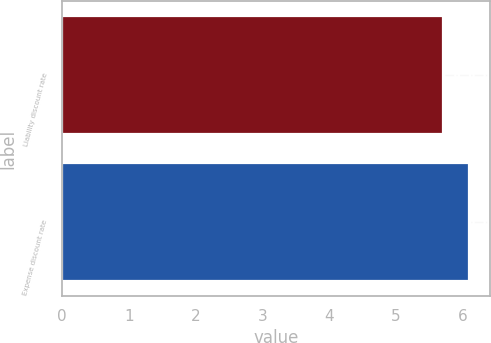Convert chart. <chart><loc_0><loc_0><loc_500><loc_500><bar_chart><fcel>Liability discount rate<fcel>Expense discount rate<nl><fcel>5.7<fcel>6.1<nl></chart> 